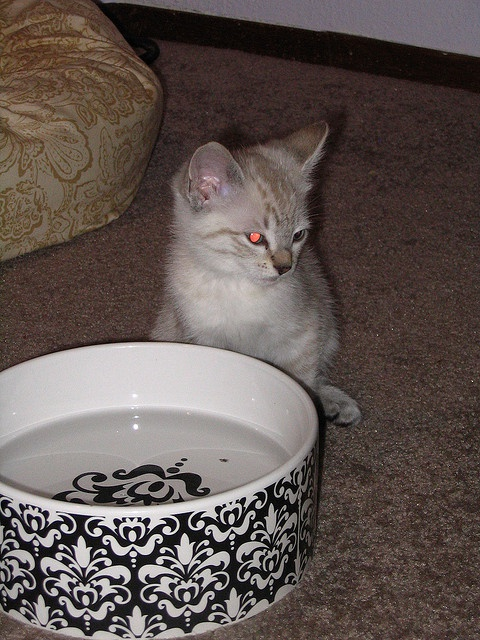Describe the objects in this image and their specific colors. I can see bowl in maroon, darkgray, lightgray, black, and gray tones and cat in maroon, darkgray, gray, and black tones in this image. 